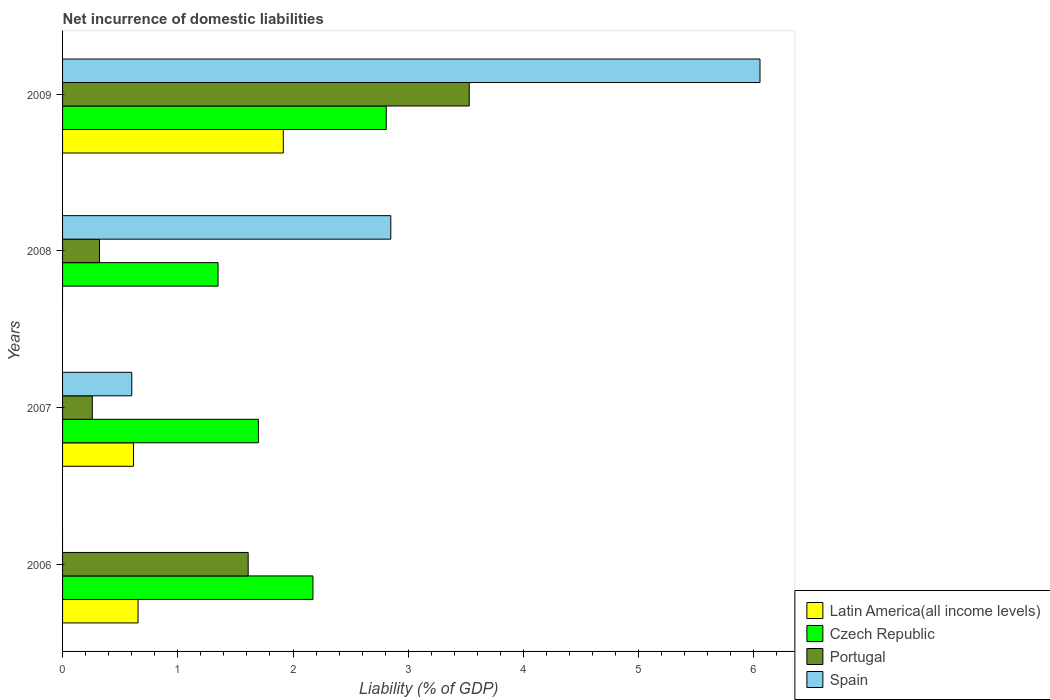How many groups of bars are there?
Provide a succinct answer. 4. Are the number of bars per tick equal to the number of legend labels?
Provide a succinct answer. No. How many bars are there on the 2nd tick from the top?
Your response must be concise. 3. How many bars are there on the 4th tick from the bottom?
Keep it short and to the point. 4. What is the label of the 1st group of bars from the top?
Give a very brief answer. 2009. What is the net incurrence of domestic liabilities in Portugal in 2009?
Provide a succinct answer. 3.53. Across all years, what is the maximum net incurrence of domestic liabilities in Latin America(all income levels)?
Offer a very short reply. 1.92. Across all years, what is the minimum net incurrence of domestic liabilities in Portugal?
Ensure brevity in your answer.  0.26. What is the total net incurrence of domestic liabilities in Latin America(all income levels) in the graph?
Provide a short and direct response. 3.19. What is the difference between the net incurrence of domestic liabilities in Czech Republic in 2008 and that in 2009?
Your response must be concise. -1.46. What is the difference between the net incurrence of domestic liabilities in Spain in 2006 and the net incurrence of domestic liabilities in Czech Republic in 2009?
Your response must be concise. -2.81. What is the average net incurrence of domestic liabilities in Czech Republic per year?
Your answer should be compact. 2.01. In the year 2006, what is the difference between the net incurrence of domestic liabilities in Portugal and net incurrence of domestic liabilities in Latin America(all income levels)?
Your response must be concise. 0.96. What is the ratio of the net incurrence of domestic liabilities in Czech Republic in 2007 to that in 2008?
Your response must be concise. 1.26. Is the net incurrence of domestic liabilities in Portugal in 2008 less than that in 2009?
Ensure brevity in your answer.  Yes. Is the difference between the net incurrence of domestic liabilities in Portugal in 2006 and 2009 greater than the difference between the net incurrence of domestic liabilities in Latin America(all income levels) in 2006 and 2009?
Keep it short and to the point. No. What is the difference between the highest and the second highest net incurrence of domestic liabilities in Portugal?
Provide a succinct answer. 1.92. What is the difference between the highest and the lowest net incurrence of domestic liabilities in Czech Republic?
Give a very brief answer. 1.46. Is the sum of the net incurrence of domestic liabilities in Latin America(all income levels) in 2006 and 2009 greater than the maximum net incurrence of domestic liabilities in Portugal across all years?
Keep it short and to the point. No. How many bars are there?
Your answer should be compact. 14. How many years are there in the graph?
Make the answer very short. 4. What is the difference between two consecutive major ticks on the X-axis?
Your answer should be compact. 1. Are the values on the major ticks of X-axis written in scientific E-notation?
Ensure brevity in your answer.  No. Does the graph contain any zero values?
Your answer should be very brief. Yes. How many legend labels are there?
Offer a terse response. 4. What is the title of the graph?
Ensure brevity in your answer.  Net incurrence of domestic liabilities. Does "Brunei Darussalam" appear as one of the legend labels in the graph?
Your response must be concise. No. What is the label or title of the X-axis?
Provide a succinct answer. Liability (% of GDP). What is the Liability (% of GDP) of Latin America(all income levels) in 2006?
Your answer should be compact. 0.66. What is the Liability (% of GDP) in Czech Republic in 2006?
Provide a short and direct response. 2.17. What is the Liability (% of GDP) in Portugal in 2006?
Make the answer very short. 1.61. What is the Liability (% of GDP) in Spain in 2006?
Offer a very short reply. 0. What is the Liability (% of GDP) in Latin America(all income levels) in 2007?
Ensure brevity in your answer.  0.62. What is the Liability (% of GDP) of Czech Republic in 2007?
Ensure brevity in your answer.  1.7. What is the Liability (% of GDP) in Portugal in 2007?
Provide a succinct answer. 0.26. What is the Liability (% of GDP) in Spain in 2007?
Give a very brief answer. 0.6. What is the Liability (% of GDP) in Latin America(all income levels) in 2008?
Offer a very short reply. 0. What is the Liability (% of GDP) of Czech Republic in 2008?
Your answer should be very brief. 1.35. What is the Liability (% of GDP) in Portugal in 2008?
Your answer should be very brief. 0.32. What is the Liability (% of GDP) in Spain in 2008?
Provide a short and direct response. 2.85. What is the Liability (% of GDP) in Latin America(all income levels) in 2009?
Offer a very short reply. 1.92. What is the Liability (% of GDP) of Czech Republic in 2009?
Give a very brief answer. 2.81. What is the Liability (% of GDP) of Portugal in 2009?
Keep it short and to the point. 3.53. What is the Liability (% of GDP) of Spain in 2009?
Your answer should be compact. 6.05. Across all years, what is the maximum Liability (% of GDP) in Latin America(all income levels)?
Your response must be concise. 1.92. Across all years, what is the maximum Liability (% of GDP) of Czech Republic?
Offer a very short reply. 2.81. Across all years, what is the maximum Liability (% of GDP) in Portugal?
Provide a succinct answer. 3.53. Across all years, what is the maximum Liability (% of GDP) of Spain?
Give a very brief answer. 6.05. Across all years, what is the minimum Liability (% of GDP) of Czech Republic?
Ensure brevity in your answer.  1.35. Across all years, what is the minimum Liability (% of GDP) in Portugal?
Your answer should be compact. 0.26. What is the total Liability (% of GDP) in Latin America(all income levels) in the graph?
Give a very brief answer. 3.19. What is the total Liability (% of GDP) of Czech Republic in the graph?
Keep it short and to the point. 8.03. What is the total Liability (% of GDP) of Portugal in the graph?
Offer a terse response. 5.72. What is the total Liability (% of GDP) of Spain in the graph?
Your response must be concise. 9.5. What is the difference between the Liability (% of GDP) of Latin America(all income levels) in 2006 and that in 2007?
Give a very brief answer. 0.04. What is the difference between the Liability (% of GDP) of Czech Republic in 2006 and that in 2007?
Your response must be concise. 0.47. What is the difference between the Liability (% of GDP) of Portugal in 2006 and that in 2007?
Provide a short and direct response. 1.35. What is the difference between the Liability (% of GDP) in Czech Republic in 2006 and that in 2008?
Ensure brevity in your answer.  0.82. What is the difference between the Liability (% of GDP) in Portugal in 2006 and that in 2008?
Ensure brevity in your answer.  1.29. What is the difference between the Liability (% of GDP) of Latin America(all income levels) in 2006 and that in 2009?
Provide a short and direct response. -1.26. What is the difference between the Liability (% of GDP) in Czech Republic in 2006 and that in 2009?
Offer a very short reply. -0.64. What is the difference between the Liability (% of GDP) in Portugal in 2006 and that in 2009?
Your answer should be compact. -1.92. What is the difference between the Liability (% of GDP) of Czech Republic in 2007 and that in 2008?
Provide a short and direct response. 0.35. What is the difference between the Liability (% of GDP) of Portugal in 2007 and that in 2008?
Offer a very short reply. -0.06. What is the difference between the Liability (% of GDP) in Spain in 2007 and that in 2008?
Offer a terse response. -2.25. What is the difference between the Liability (% of GDP) of Latin America(all income levels) in 2007 and that in 2009?
Offer a very short reply. -1.3. What is the difference between the Liability (% of GDP) in Czech Republic in 2007 and that in 2009?
Keep it short and to the point. -1.11. What is the difference between the Liability (% of GDP) of Portugal in 2007 and that in 2009?
Ensure brevity in your answer.  -3.27. What is the difference between the Liability (% of GDP) of Spain in 2007 and that in 2009?
Your answer should be compact. -5.45. What is the difference between the Liability (% of GDP) of Czech Republic in 2008 and that in 2009?
Your response must be concise. -1.46. What is the difference between the Liability (% of GDP) in Portugal in 2008 and that in 2009?
Make the answer very short. -3.21. What is the difference between the Liability (% of GDP) in Spain in 2008 and that in 2009?
Provide a short and direct response. -3.2. What is the difference between the Liability (% of GDP) of Latin America(all income levels) in 2006 and the Liability (% of GDP) of Czech Republic in 2007?
Provide a succinct answer. -1.04. What is the difference between the Liability (% of GDP) in Latin America(all income levels) in 2006 and the Liability (% of GDP) in Portugal in 2007?
Keep it short and to the point. 0.4. What is the difference between the Liability (% of GDP) in Latin America(all income levels) in 2006 and the Liability (% of GDP) in Spain in 2007?
Offer a terse response. 0.05. What is the difference between the Liability (% of GDP) of Czech Republic in 2006 and the Liability (% of GDP) of Portugal in 2007?
Offer a very short reply. 1.91. What is the difference between the Liability (% of GDP) in Czech Republic in 2006 and the Liability (% of GDP) in Spain in 2007?
Your answer should be very brief. 1.57. What is the difference between the Liability (% of GDP) in Portugal in 2006 and the Liability (% of GDP) in Spain in 2007?
Keep it short and to the point. 1.01. What is the difference between the Liability (% of GDP) of Latin America(all income levels) in 2006 and the Liability (% of GDP) of Czech Republic in 2008?
Make the answer very short. -0.69. What is the difference between the Liability (% of GDP) in Latin America(all income levels) in 2006 and the Liability (% of GDP) in Portugal in 2008?
Offer a terse response. 0.33. What is the difference between the Liability (% of GDP) of Latin America(all income levels) in 2006 and the Liability (% of GDP) of Spain in 2008?
Your answer should be very brief. -2.19. What is the difference between the Liability (% of GDP) of Czech Republic in 2006 and the Liability (% of GDP) of Portugal in 2008?
Your answer should be compact. 1.85. What is the difference between the Liability (% of GDP) in Czech Republic in 2006 and the Liability (% of GDP) in Spain in 2008?
Your answer should be very brief. -0.68. What is the difference between the Liability (% of GDP) of Portugal in 2006 and the Liability (% of GDP) of Spain in 2008?
Your response must be concise. -1.24. What is the difference between the Liability (% of GDP) in Latin America(all income levels) in 2006 and the Liability (% of GDP) in Czech Republic in 2009?
Give a very brief answer. -2.15. What is the difference between the Liability (% of GDP) of Latin America(all income levels) in 2006 and the Liability (% of GDP) of Portugal in 2009?
Ensure brevity in your answer.  -2.87. What is the difference between the Liability (% of GDP) in Latin America(all income levels) in 2006 and the Liability (% of GDP) in Spain in 2009?
Ensure brevity in your answer.  -5.4. What is the difference between the Liability (% of GDP) in Czech Republic in 2006 and the Liability (% of GDP) in Portugal in 2009?
Provide a succinct answer. -1.36. What is the difference between the Liability (% of GDP) in Czech Republic in 2006 and the Liability (% of GDP) in Spain in 2009?
Offer a very short reply. -3.88. What is the difference between the Liability (% of GDP) in Portugal in 2006 and the Liability (% of GDP) in Spain in 2009?
Your answer should be very brief. -4.44. What is the difference between the Liability (% of GDP) in Latin America(all income levels) in 2007 and the Liability (% of GDP) in Czech Republic in 2008?
Provide a short and direct response. -0.73. What is the difference between the Liability (% of GDP) in Latin America(all income levels) in 2007 and the Liability (% of GDP) in Portugal in 2008?
Offer a very short reply. 0.3. What is the difference between the Liability (% of GDP) in Latin America(all income levels) in 2007 and the Liability (% of GDP) in Spain in 2008?
Ensure brevity in your answer.  -2.23. What is the difference between the Liability (% of GDP) of Czech Republic in 2007 and the Liability (% of GDP) of Portugal in 2008?
Your answer should be very brief. 1.38. What is the difference between the Liability (% of GDP) in Czech Republic in 2007 and the Liability (% of GDP) in Spain in 2008?
Keep it short and to the point. -1.15. What is the difference between the Liability (% of GDP) of Portugal in 2007 and the Liability (% of GDP) of Spain in 2008?
Provide a short and direct response. -2.59. What is the difference between the Liability (% of GDP) in Latin America(all income levels) in 2007 and the Liability (% of GDP) in Czech Republic in 2009?
Make the answer very short. -2.19. What is the difference between the Liability (% of GDP) in Latin America(all income levels) in 2007 and the Liability (% of GDP) in Portugal in 2009?
Your answer should be very brief. -2.91. What is the difference between the Liability (% of GDP) in Latin America(all income levels) in 2007 and the Liability (% of GDP) in Spain in 2009?
Make the answer very short. -5.44. What is the difference between the Liability (% of GDP) of Czech Republic in 2007 and the Liability (% of GDP) of Portugal in 2009?
Give a very brief answer. -1.83. What is the difference between the Liability (% of GDP) in Czech Republic in 2007 and the Liability (% of GDP) in Spain in 2009?
Your response must be concise. -4.35. What is the difference between the Liability (% of GDP) in Portugal in 2007 and the Liability (% of GDP) in Spain in 2009?
Your answer should be very brief. -5.79. What is the difference between the Liability (% of GDP) of Czech Republic in 2008 and the Liability (% of GDP) of Portugal in 2009?
Your answer should be very brief. -2.18. What is the difference between the Liability (% of GDP) of Czech Republic in 2008 and the Liability (% of GDP) of Spain in 2009?
Make the answer very short. -4.7. What is the difference between the Liability (% of GDP) in Portugal in 2008 and the Liability (% of GDP) in Spain in 2009?
Ensure brevity in your answer.  -5.73. What is the average Liability (% of GDP) in Latin America(all income levels) per year?
Offer a terse response. 0.8. What is the average Liability (% of GDP) in Czech Republic per year?
Give a very brief answer. 2.01. What is the average Liability (% of GDP) in Portugal per year?
Offer a very short reply. 1.43. What is the average Liability (% of GDP) in Spain per year?
Provide a short and direct response. 2.38. In the year 2006, what is the difference between the Liability (% of GDP) in Latin America(all income levels) and Liability (% of GDP) in Czech Republic?
Provide a succinct answer. -1.52. In the year 2006, what is the difference between the Liability (% of GDP) in Latin America(all income levels) and Liability (% of GDP) in Portugal?
Your response must be concise. -0.96. In the year 2006, what is the difference between the Liability (% of GDP) in Czech Republic and Liability (% of GDP) in Portugal?
Your response must be concise. 0.56. In the year 2007, what is the difference between the Liability (% of GDP) of Latin America(all income levels) and Liability (% of GDP) of Czech Republic?
Ensure brevity in your answer.  -1.08. In the year 2007, what is the difference between the Liability (% of GDP) in Latin America(all income levels) and Liability (% of GDP) in Portugal?
Offer a very short reply. 0.36. In the year 2007, what is the difference between the Liability (% of GDP) of Latin America(all income levels) and Liability (% of GDP) of Spain?
Offer a very short reply. 0.02. In the year 2007, what is the difference between the Liability (% of GDP) in Czech Republic and Liability (% of GDP) in Portugal?
Offer a very short reply. 1.44. In the year 2007, what is the difference between the Liability (% of GDP) in Czech Republic and Liability (% of GDP) in Spain?
Your response must be concise. 1.1. In the year 2007, what is the difference between the Liability (% of GDP) in Portugal and Liability (% of GDP) in Spain?
Offer a very short reply. -0.34. In the year 2008, what is the difference between the Liability (% of GDP) of Czech Republic and Liability (% of GDP) of Portugal?
Make the answer very short. 1.03. In the year 2008, what is the difference between the Liability (% of GDP) of Czech Republic and Liability (% of GDP) of Spain?
Provide a succinct answer. -1.5. In the year 2008, what is the difference between the Liability (% of GDP) of Portugal and Liability (% of GDP) of Spain?
Ensure brevity in your answer.  -2.53. In the year 2009, what is the difference between the Liability (% of GDP) of Latin America(all income levels) and Liability (% of GDP) of Czech Republic?
Provide a succinct answer. -0.89. In the year 2009, what is the difference between the Liability (% of GDP) of Latin America(all income levels) and Liability (% of GDP) of Portugal?
Give a very brief answer. -1.61. In the year 2009, what is the difference between the Liability (% of GDP) in Latin America(all income levels) and Liability (% of GDP) in Spain?
Offer a terse response. -4.14. In the year 2009, what is the difference between the Liability (% of GDP) of Czech Republic and Liability (% of GDP) of Portugal?
Ensure brevity in your answer.  -0.72. In the year 2009, what is the difference between the Liability (% of GDP) of Czech Republic and Liability (% of GDP) of Spain?
Ensure brevity in your answer.  -3.24. In the year 2009, what is the difference between the Liability (% of GDP) in Portugal and Liability (% of GDP) in Spain?
Ensure brevity in your answer.  -2.52. What is the ratio of the Liability (% of GDP) of Latin America(all income levels) in 2006 to that in 2007?
Give a very brief answer. 1.06. What is the ratio of the Liability (% of GDP) in Czech Republic in 2006 to that in 2007?
Give a very brief answer. 1.28. What is the ratio of the Liability (% of GDP) of Portugal in 2006 to that in 2007?
Make the answer very short. 6.24. What is the ratio of the Liability (% of GDP) of Czech Republic in 2006 to that in 2008?
Your answer should be compact. 1.61. What is the ratio of the Liability (% of GDP) of Portugal in 2006 to that in 2008?
Offer a terse response. 5.02. What is the ratio of the Liability (% of GDP) in Latin America(all income levels) in 2006 to that in 2009?
Your answer should be compact. 0.34. What is the ratio of the Liability (% of GDP) in Czech Republic in 2006 to that in 2009?
Provide a succinct answer. 0.77. What is the ratio of the Liability (% of GDP) in Portugal in 2006 to that in 2009?
Your answer should be compact. 0.46. What is the ratio of the Liability (% of GDP) in Czech Republic in 2007 to that in 2008?
Give a very brief answer. 1.26. What is the ratio of the Liability (% of GDP) in Portugal in 2007 to that in 2008?
Provide a short and direct response. 0.81. What is the ratio of the Liability (% of GDP) in Spain in 2007 to that in 2008?
Give a very brief answer. 0.21. What is the ratio of the Liability (% of GDP) of Latin America(all income levels) in 2007 to that in 2009?
Give a very brief answer. 0.32. What is the ratio of the Liability (% of GDP) in Czech Republic in 2007 to that in 2009?
Provide a succinct answer. 0.6. What is the ratio of the Liability (% of GDP) in Portugal in 2007 to that in 2009?
Keep it short and to the point. 0.07. What is the ratio of the Liability (% of GDP) in Spain in 2007 to that in 2009?
Your answer should be very brief. 0.1. What is the ratio of the Liability (% of GDP) in Czech Republic in 2008 to that in 2009?
Provide a short and direct response. 0.48. What is the ratio of the Liability (% of GDP) of Portugal in 2008 to that in 2009?
Your answer should be compact. 0.09. What is the ratio of the Liability (% of GDP) in Spain in 2008 to that in 2009?
Your answer should be very brief. 0.47. What is the difference between the highest and the second highest Liability (% of GDP) of Latin America(all income levels)?
Provide a short and direct response. 1.26. What is the difference between the highest and the second highest Liability (% of GDP) of Czech Republic?
Make the answer very short. 0.64. What is the difference between the highest and the second highest Liability (% of GDP) in Portugal?
Give a very brief answer. 1.92. What is the difference between the highest and the second highest Liability (% of GDP) of Spain?
Make the answer very short. 3.2. What is the difference between the highest and the lowest Liability (% of GDP) of Latin America(all income levels)?
Offer a terse response. 1.92. What is the difference between the highest and the lowest Liability (% of GDP) in Czech Republic?
Provide a succinct answer. 1.46. What is the difference between the highest and the lowest Liability (% of GDP) of Portugal?
Ensure brevity in your answer.  3.27. What is the difference between the highest and the lowest Liability (% of GDP) of Spain?
Give a very brief answer. 6.05. 